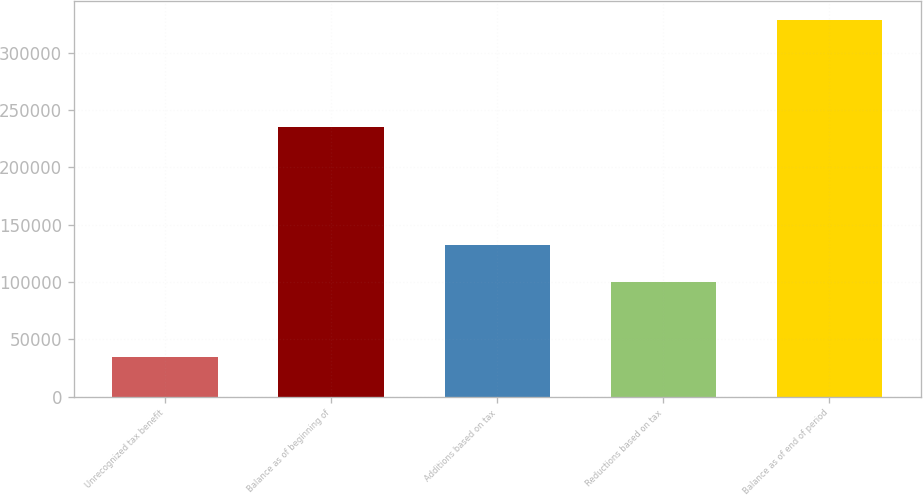Convert chart to OTSL. <chart><loc_0><loc_0><loc_500><loc_500><bar_chart><fcel>Unrecognized tax benefit<fcel>Balance as of beginning of<fcel>Additions based on tax<fcel>Reductions based on tax<fcel>Balance as of end of period<nl><fcel>34460.2<fcel>235067<fcel>132624<fcel>99902.6<fcel>328951<nl></chart> 